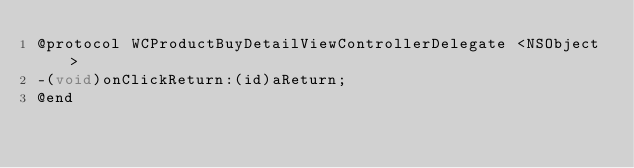<code> <loc_0><loc_0><loc_500><loc_500><_C_>@protocol WCProductBuyDetailViewControllerDelegate <NSObject>
-(void)onClickReturn:(id)aReturn;
@end

</code> 